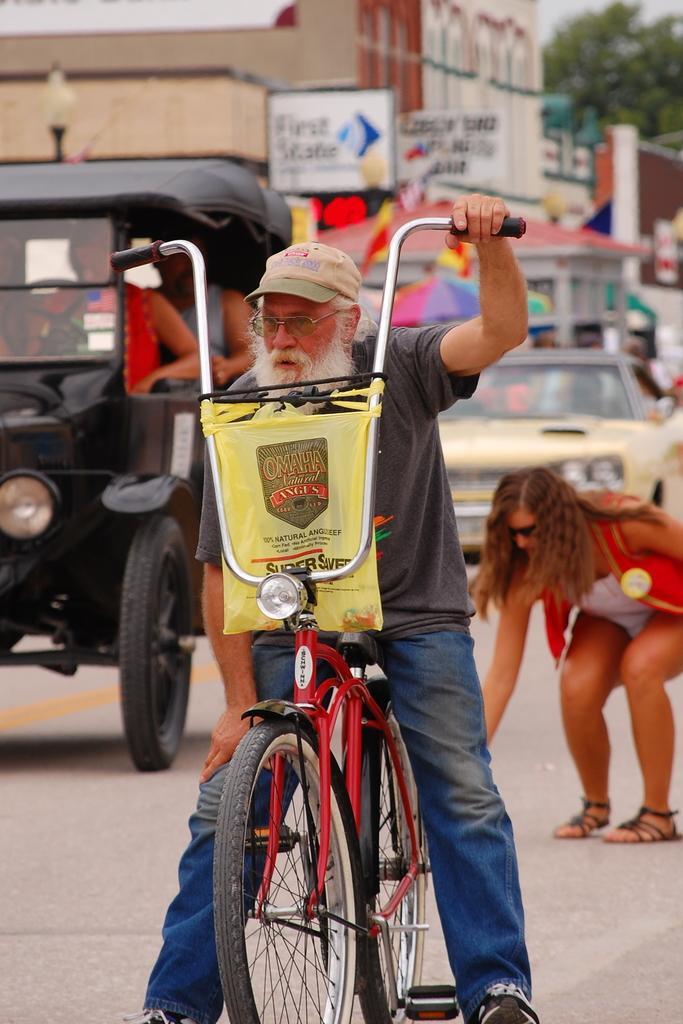How would you summarize this image in a sentence or two? In this image I can see a man with his cycle and he is wearing a cap and a specs. In the background I can see few more people and also few vehicles. 